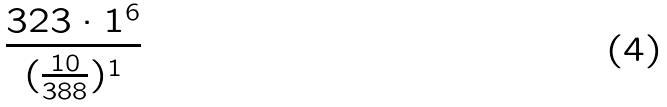<formula> <loc_0><loc_0><loc_500><loc_500>\frac { 3 2 3 \cdot 1 ^ { 6 } } { ( \frac { 1 0 } { 3 8 8 } ) ^ { 1 } }</formula> 